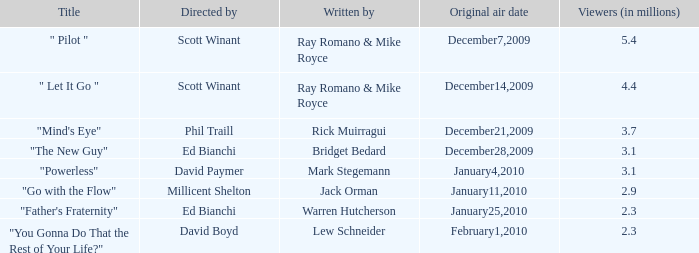How many viewers (in millions) did episode 1 have? 5.4. 